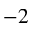Convert formula to latex. <formula><loc_0><loc_0><loc_500><loc_500>^ { - 2 }</formula> 